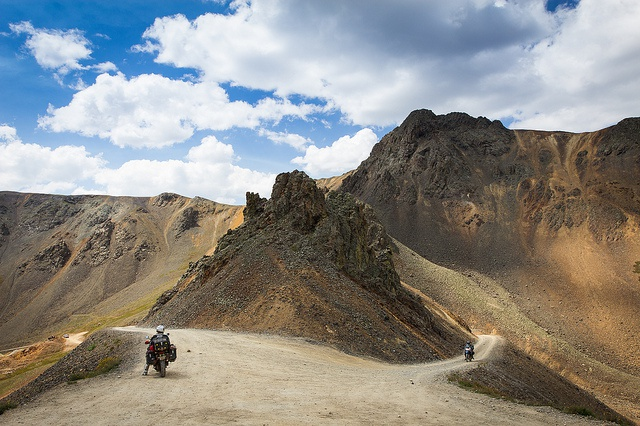Describe the objects in this image and their specific colors. I can see motorcycle in gray, black, maroon, and darkgreen tones, people in gray, black, darkgray, and lightgray tones, motorcycle in gray, black, and maroon tones, and people in gray and black tones in this image. 